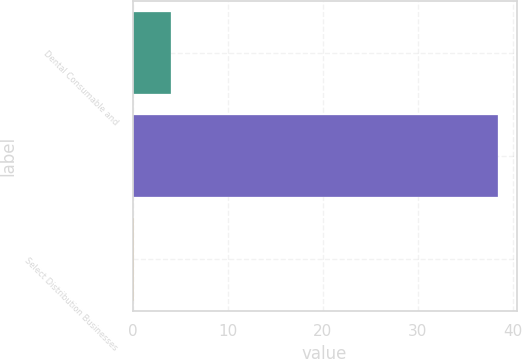Convert chart to OTSL. <chart><loc_0><loc_0><loc_500><loc_500><bar_chart><fcel>Dental Consumable and<fcel>Unnamed: 1<fcel>Select Distribution Businesses<nl><fcel>4.03<fcel>38.5<fcel>0.2<nl></chart> 